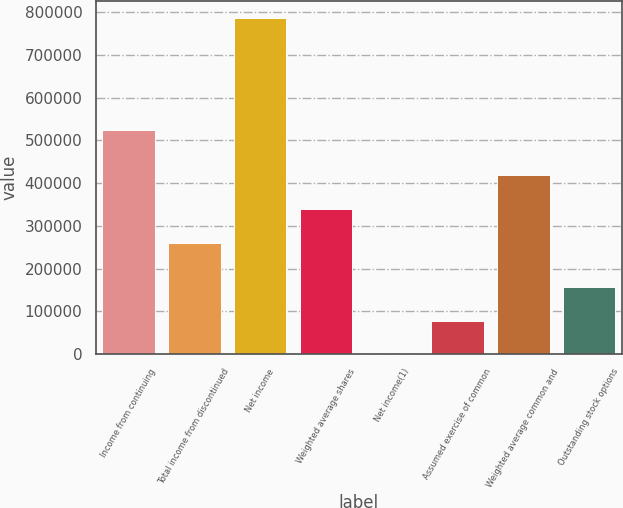Convert chart. <chart><loc_0><loc_0><loc_500><loc_500><bar_chart><fcel>Income from continuing<fcel>Total income from discontinued<fcel>Net income<fcel>Weighted average shares<fcel>Net income(1)<fcel>Assumed exercise of common<fcel>Weighted average common and<fcel>Outstanding stock options<nl><fcel>525177<fcel>261107<fcel>786284<fcel>339735<fcel>2.69<fcel>78630.8<fcel>418363<fcel>157259<nl></chart> 